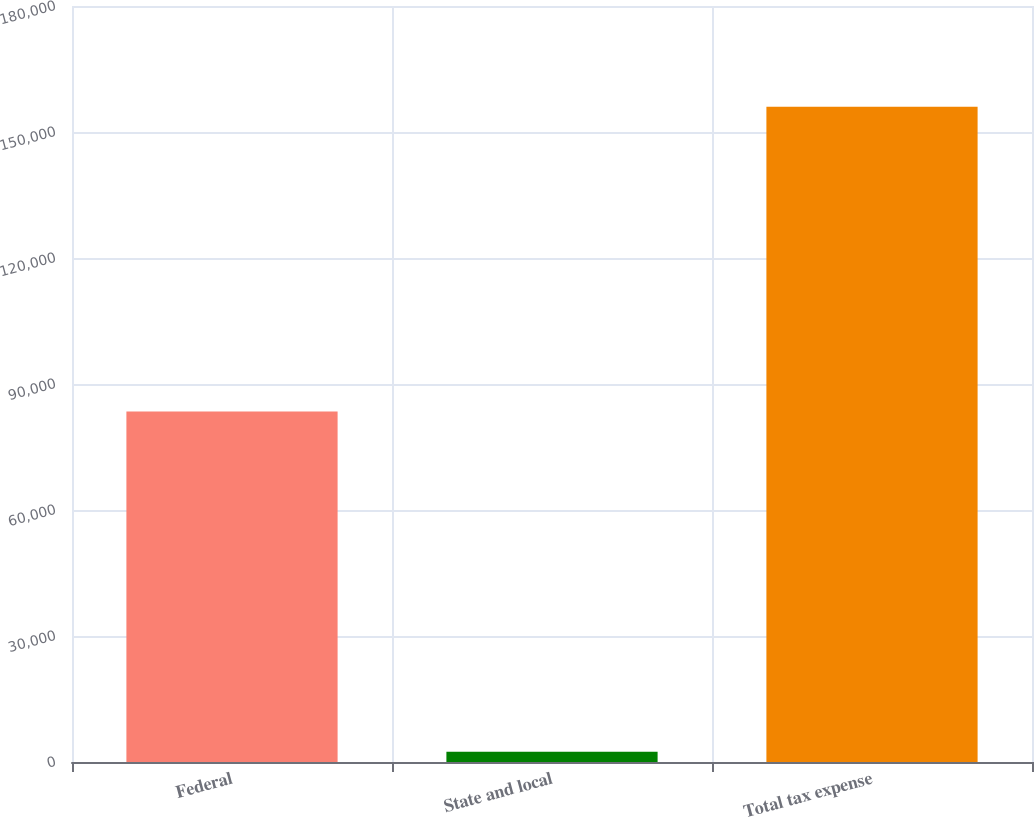Convert chart to OTSL. <chart><loc_0><loc_0><loc_500><loc_500><bar_chart><fcel>Federal<fcel>State and local<fcel>Total tax expense<nl><fcel>83428<fcel>2433<fcel>156023<nl></chart> 